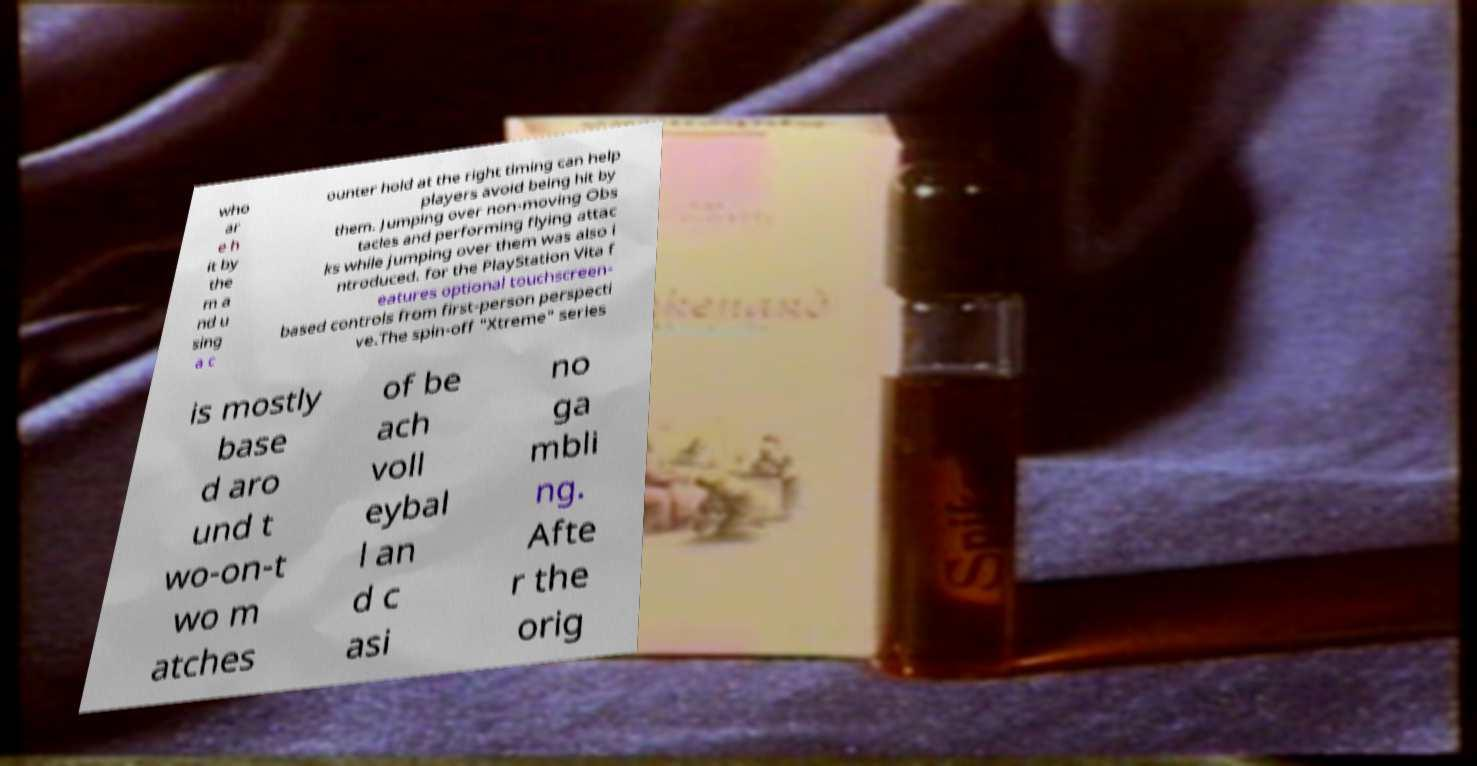There's text embedded in this image that I need extracted. Can you transcribe it verbatim? who ar e h it by the m a nd u sing a c ounter hold at the right timing can help players avoid being hit by them. Jumping over non-moving Obs tacles and performing flying attac ks while jumping over them was also i ntroduced. for the PlayStation Vita f eatures optional touchscreen- based controls from first-person perspecti ve.The spin-off "Xtreme" series is mostly base d aro und t wo-on-t wo m atches of be ach voll eybal l an d c asi no ga mbli ng. Afte r the orig 